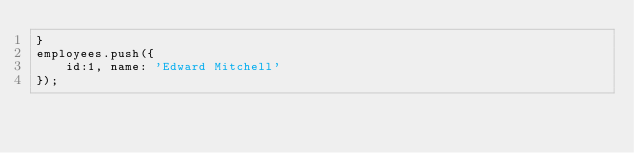Convert code to text. <code><loc_0><loc_0><loc_500><loc_500><_JavaScript_>}
employees.push({
    id:1, name: 'Edward Mitchell'
});
</code> 